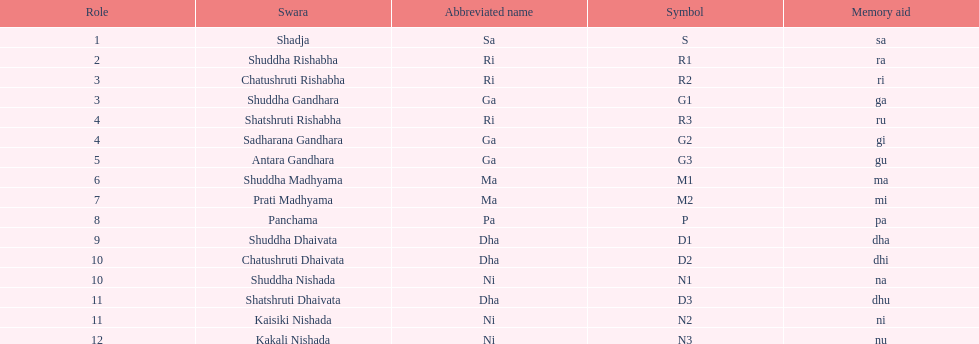What is the total number of positions listed? 16. 